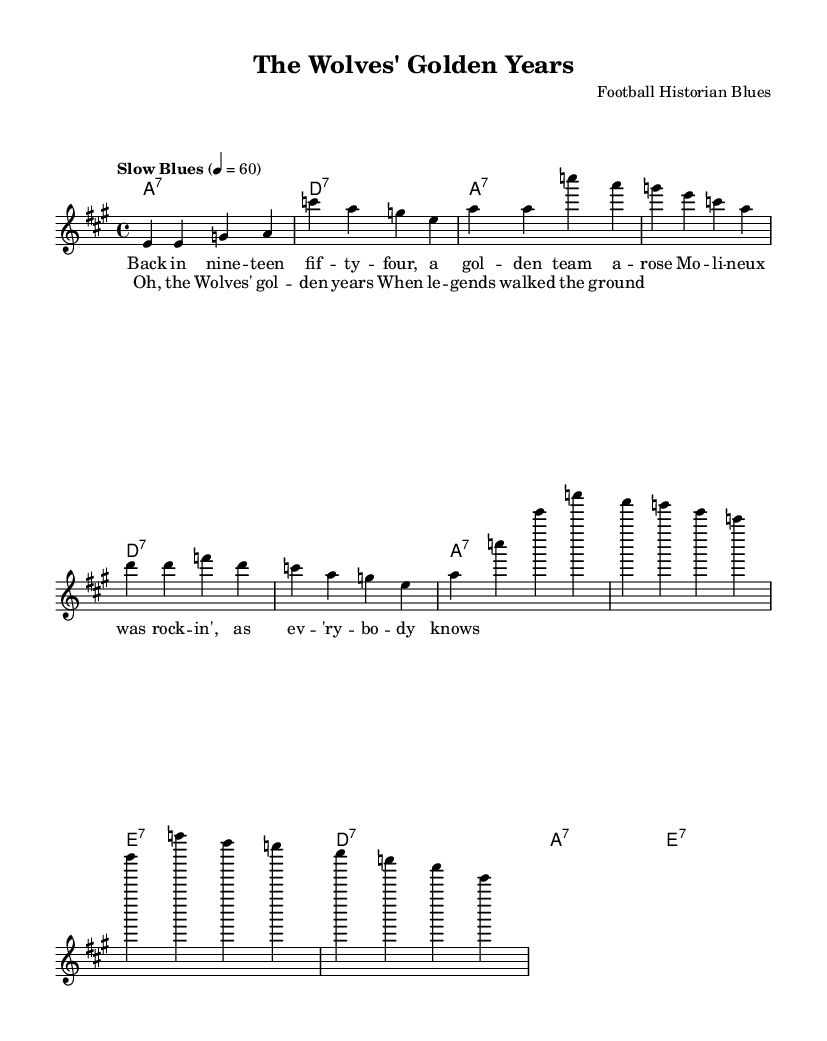What is the key signature of this music? The key signature is A major, which has three sharps (F#, C#, and G#).
Answer: A major What is the time signature of the piece? The time signature is indicated as 4/4, which means there are four beats per measure.
Answer: 4/4 What tempo marking is indicated for this piece? The tempo marking given is "Slow Blues," which informs the performer to play the music at a slow pace.
Answer: Slow Blues How many measures are there in the verse? The verse consists of four measures, as indicated by the number of distinct musical phrases and their arrangement.
Answer: Four measures What predominant chord type is used in the harmonies? The predominant chord type used in the harmonies is seventh chords, as indicated by the "7" after each chord name.
Answer: Seventh chords In what year does the song reference a significant milestone for Wolverhampton? The song references the year nineteen forty-four, highlighting a notable moment in the club’s history.
Answer: Nineteen forty-four 